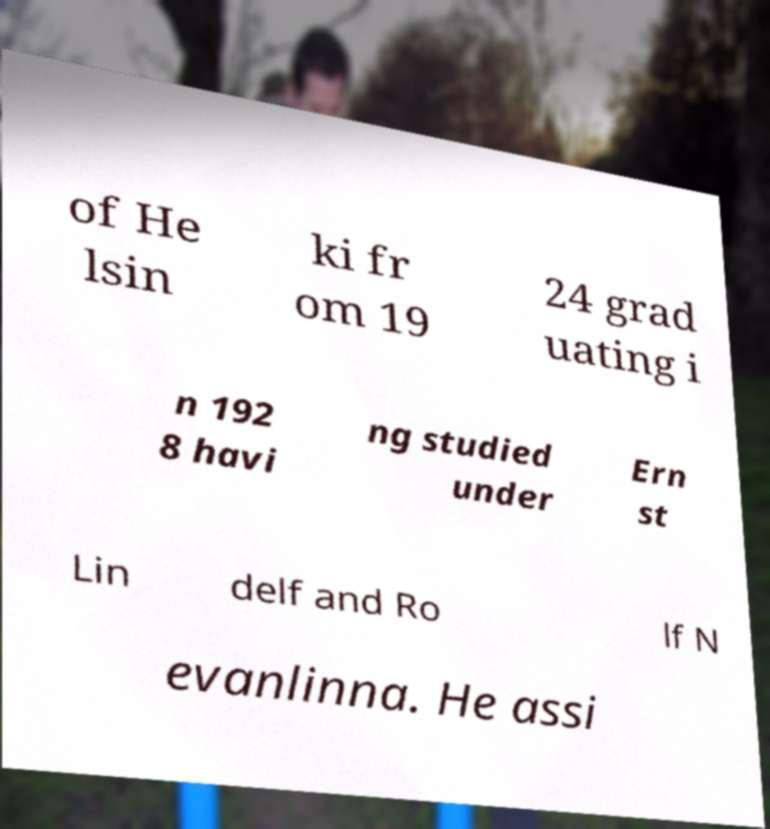Could you extract and type out the text from this image? of He lsin ki fr om 19 24 grad uating i n 192 8 havi ng studied under Ern st Lin delf and Ro lf N evanlinna. He assi 